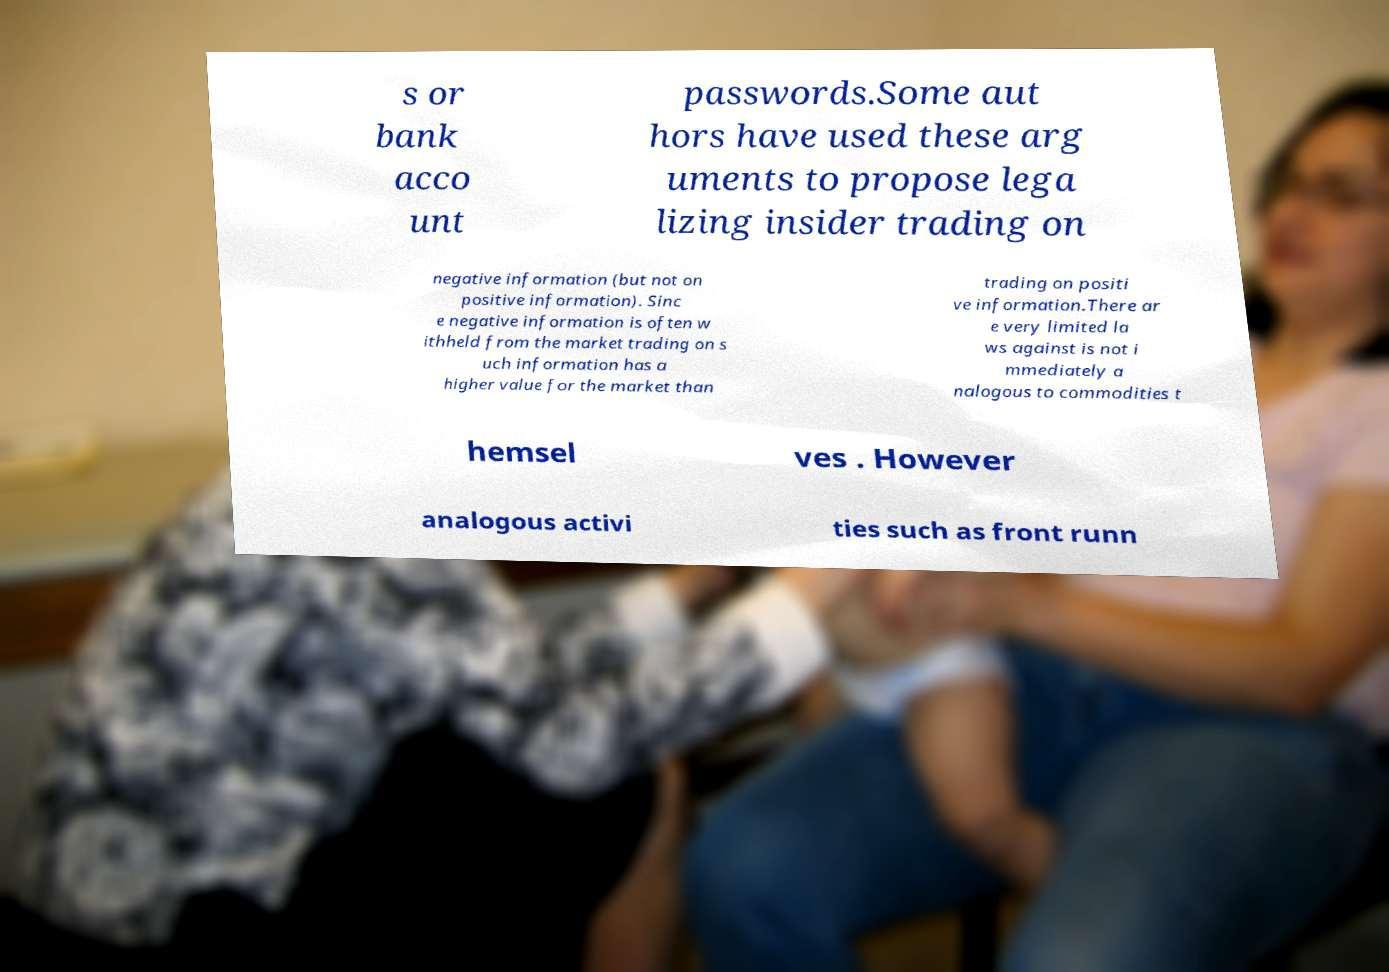Could you assist in decoding the text presented in this image and type it out clearly? s or bank acco unt passwords.Some aut hors have used these arg uments to propose lega lizing insider trading on negative information (but not on positive information). Sinc e negative information is often w ithheld from the market trading on s uch information has a higher value for the market than trading on positi ve information.There ar e very limited la ws against is not i mmediately a nalogous to commodities t hemsel ves . However analogous activi ties such as front runn 